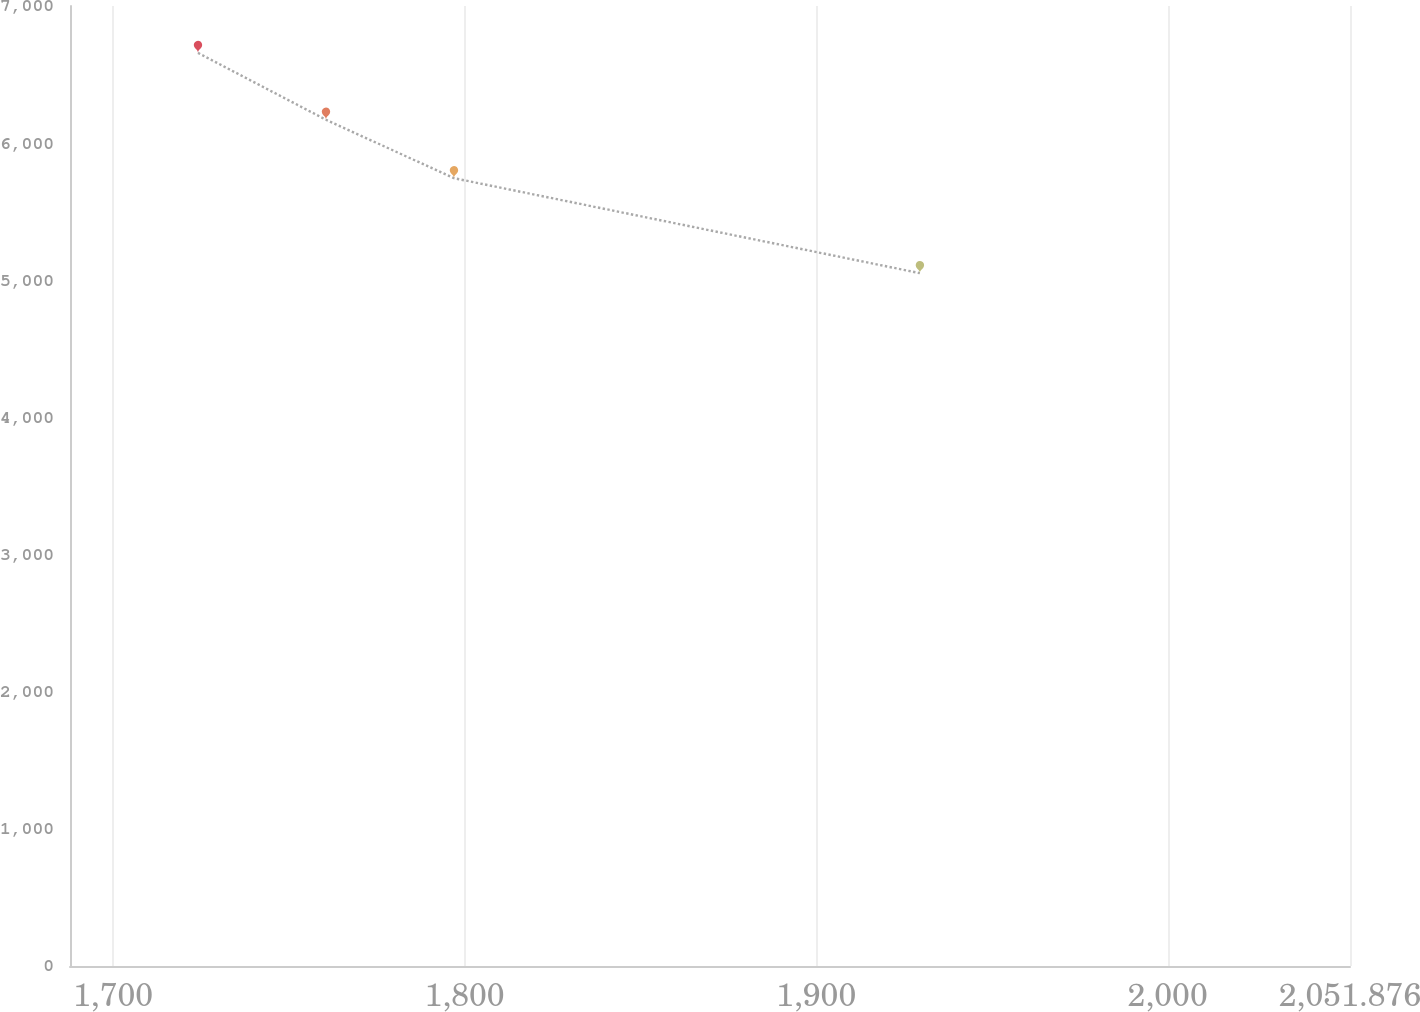<chart> <loc_0><loc_0><loc_500><loc_500><line_chart><ecel><fcel>Amount<nl><fcel>1724.15<fcel>6657.76<nl><fcel>1760.56<fcel>6170.42<nl><fcel>1796.97<fcel>5744.49<nl><fcel>1929.52<fcel>5051.96<nl><fcel>2088.29<fcel>4170.36<nl></chart> 